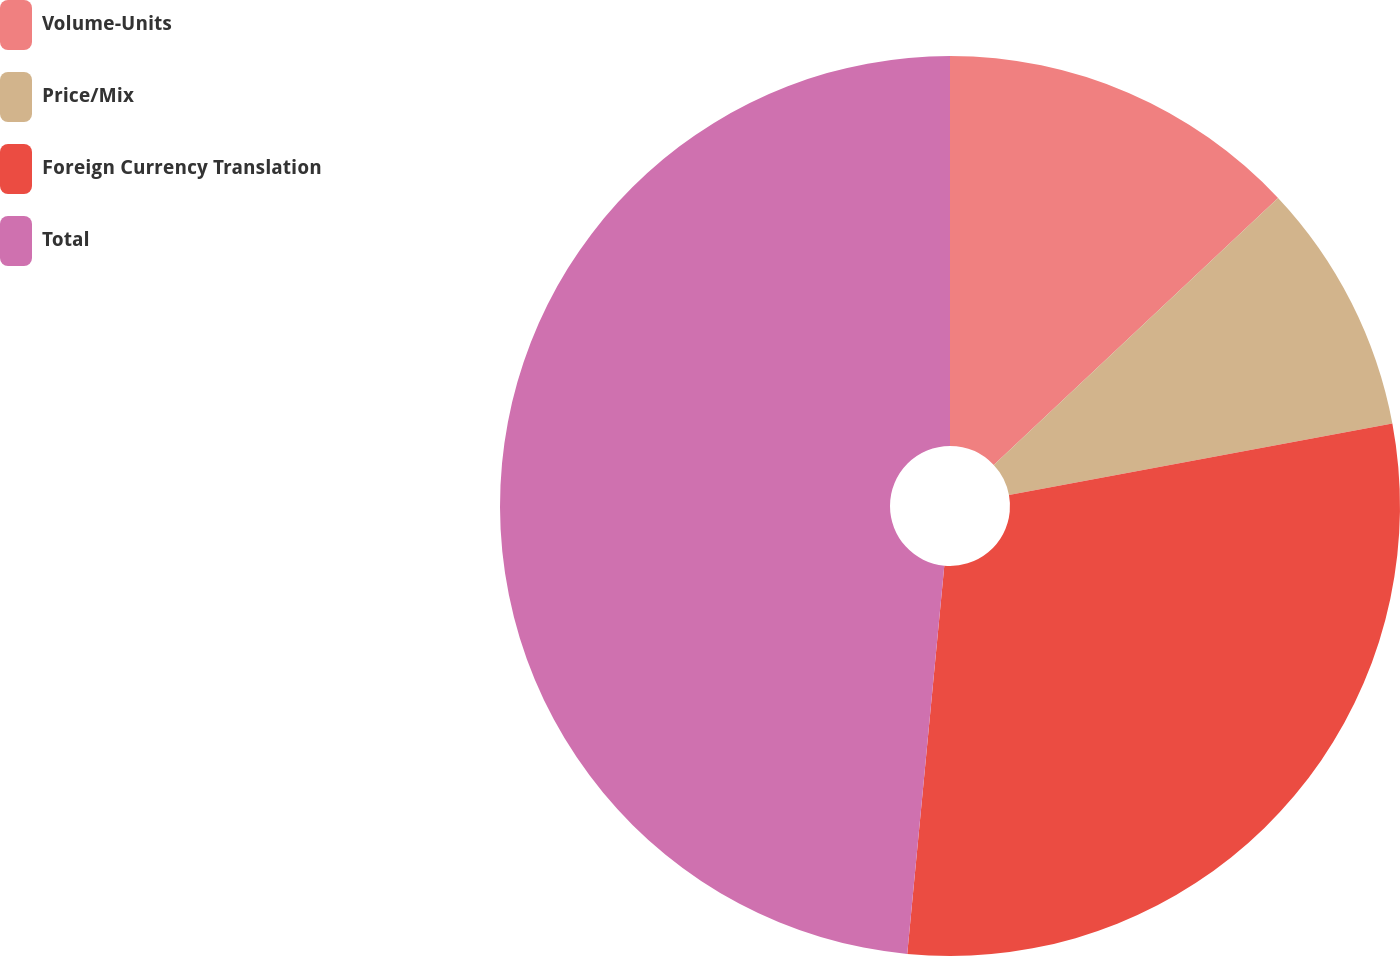Convert chart. <chart><loc_0><loc_0><loc_500><loc_500><pie_chart><fcel>Volume-Units<fcel>Price/Mix<fcel>Foreign Currency Translation<fcel>Total<nl><fcel>13.0%<fcel>9.06%<fcel>29.45%<fcel>48.48%<nl></chart> 